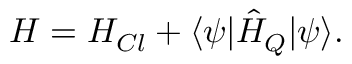Convert formula to latex. <formula><loc_0><loc_0><loc_500><loc_500>H = H _ { C l } + \langle \psi | \hat { H } _ { Q } | \psi \rangle .</formula> 